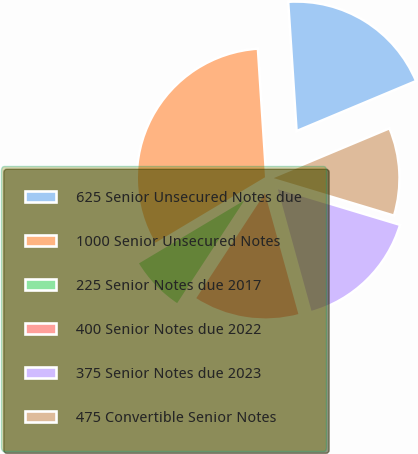Convert chart to OTSL. <chart><loc_0><loc_0><loc_500><loc_500><pie_chart><fcel>625 Senior Unsecured Notes due<fcel>1000 Senior Unsecured Notes<fcel>225 Senior Notes due 2017<fcel>400 Senior Notes due 2022<fcel>375 Senior Notes due 2023<fcel>475 Convertible Senior Notes<nl><fcel>19.72%<fcel>32.54%<fcel>7.21%<fcel>13.51%<fcel>16.05%<fcel>10.97%<nl></chart> 